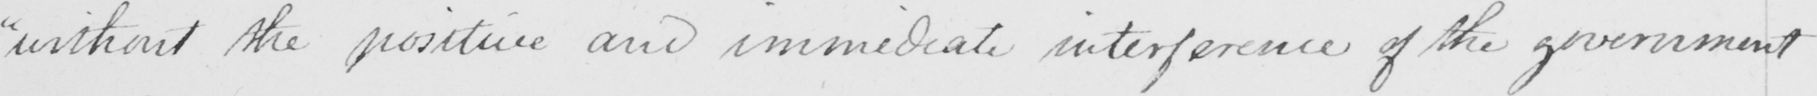Can you tell me what this handwritten text says? " without the positive and immediate interference of the government 